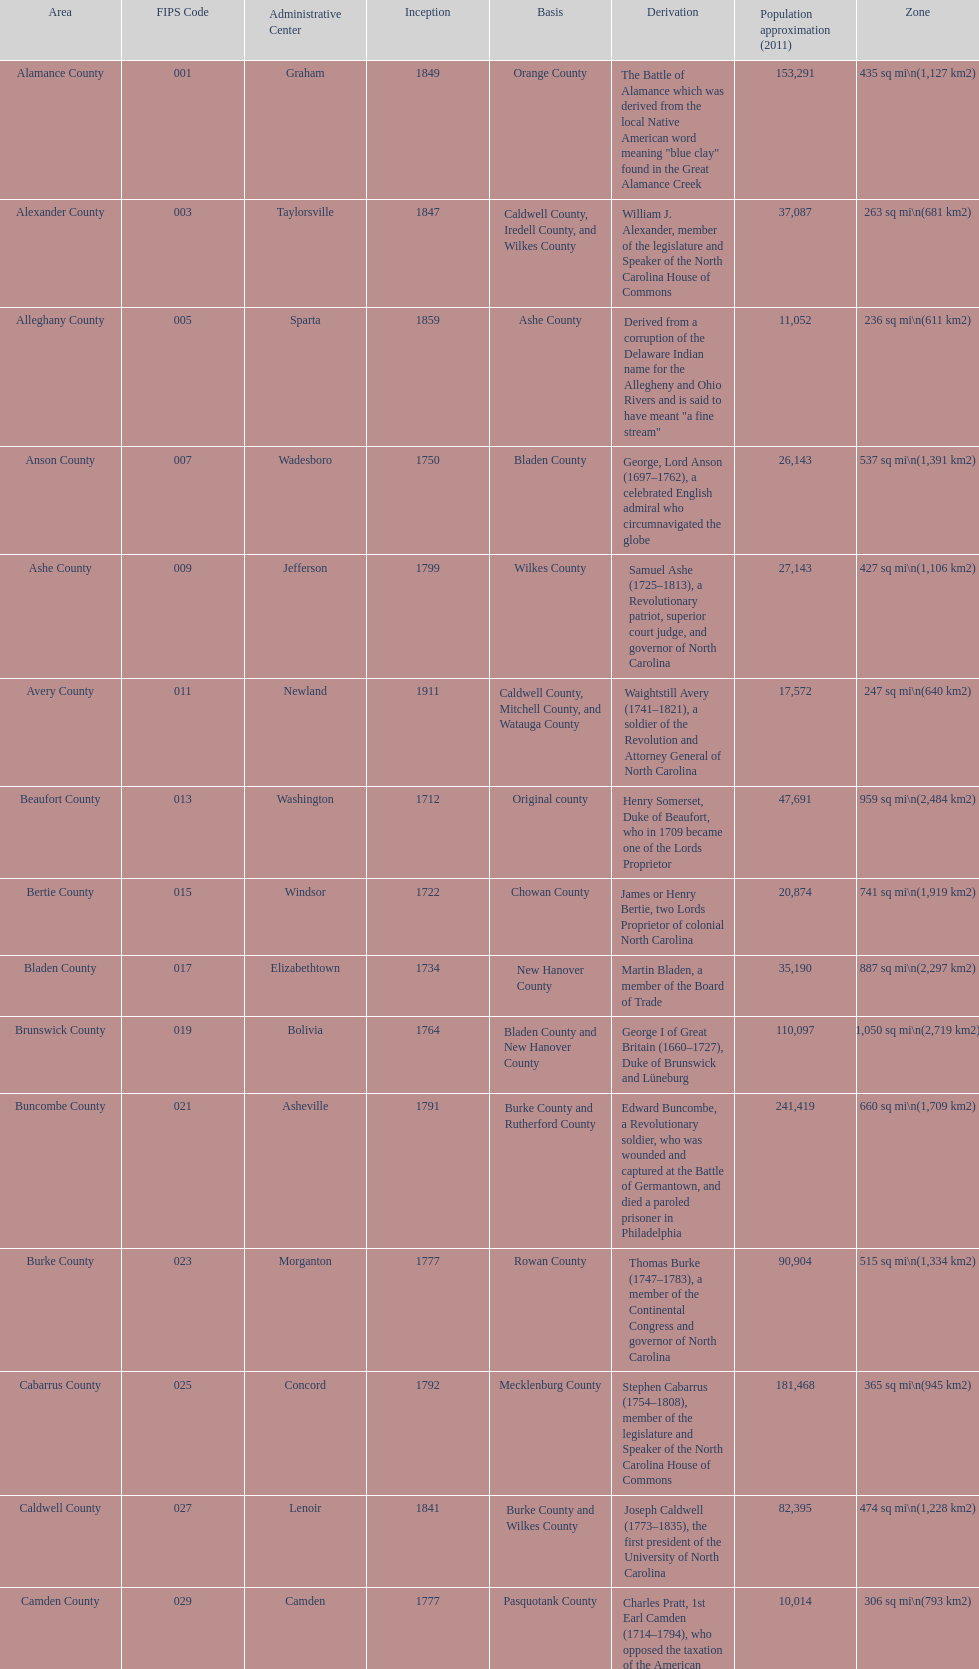Other than mecklenburg which county has the largest population? Wake County. 